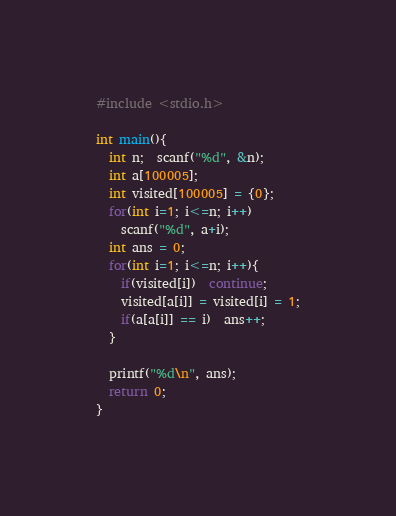<code> <loc_0><loc_0><loc_500><loc_500><_C_>#include <stdio.h>

int main(){
  int n;  scanf("%d", &n);
  int a[100005];
  int visited[100005] = {0};
  for(int i=1; i<=n; i++)
    scanf("%d", a+i);
  int ans = 0;
  for(int i=1; i<=n; i++){
    if(visited[i])  continue;
    visited[a[i]] = visited[i] = 1;
    if(a[a[i]] == i)  ans++;
  }

  printf("%d\n", ans);
  return 0;
}
</code> 